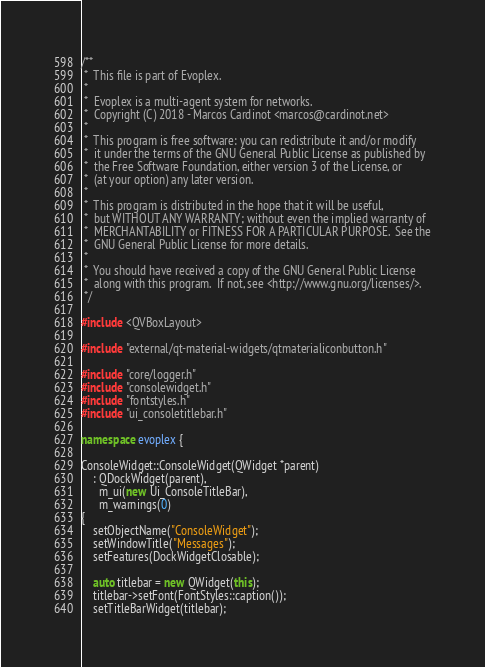Convert code to text. <code><loc_0><loc_0><loc_500><loc_500><_C++_>/**
 *  This file is part of Evoplex.
 *
 *  Evoplex is a multi-agent system for networks.
 *  Copyright (C) 2018 - Marcos Cardinot <marcos@cardinot.net>
 *
 *  This program is free software: you can redistribute it and/or modify
 *  it under the terms of the GNU General Public License as published by
 *  the Free Software Foundation, either version 3 of the License, or
 *  (at your option) any later version.
 *
 *  This program is distributed in the hope that it will be useful,
 *  but WITHOUT ANY WARRANTY; without even the implied warranty of
 *  MERCHANTABILITY or FITNESS FOR A PARTICULAR PURPOSE.  See the
 *  GNU General Public License for more details.
 *
 *  You should have received a copy of the GNU General Public License
 *  along with this program.  If not, see <http://www.gnu.org/licenses/>.
 */

#include <QVBoxLayout>

#include "external/qt-material-widgets/qtmaterialiconbutton.h"

#include "core/logger.h"
#include "consolewidget.h"
#include "fontstyles.h"
#include "ui_consoletitlebar.h"

namespace evoplex {

ConsoleWidget::ConsoleWidget(QWidget *parent)
    : QDockWidget(parent),
      m_ui(new Ui_ConsoleTitleBar),
      m_warnings(0)
{
    setObjectName("ConsoleWidget");
    setWindowTitle("Messages");
    setFeatures(DockWidgetClosable);

    auto titlebar = new QWidget(this);
    titlebar->setFont(FontStyles::caption());
    setTitleBarWidget(titlebar);</code> 